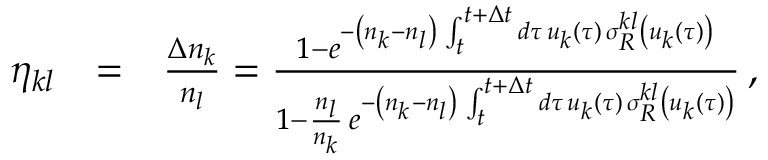Convert formula to latex. <formula><loc_0><loc_0><loc_500><loc_500>\begin{array} { r l r } { \eta _ { k l } } & { = } & { \frac { \Delta n _ { k } } { n _ { l } } = \frac { 1 - e ^ { - \left ( n _ { k } - n _ { l } \right ) \, \int _ { t } ^ { t + \Delta t } d \tau \, u _ { k } ( \tau ) \, \sigma _ { R } ^ { k l } \left ( u _ { k } ( \tau ) \right ) } } { 1 - \frac { n _ { l } } { n _ { k } } \, e ^ { - \left ( n _ { k } - n _ { l } \right ) \, \int _ { t } ^ { t + \Delta t } d \tau \, u _ { k } ( \tau ) \, \sigma _ { R } ^ { k l } \left ( u _ { k } ( \tau ) \right ) } } \, , } \end{array}</formula> 